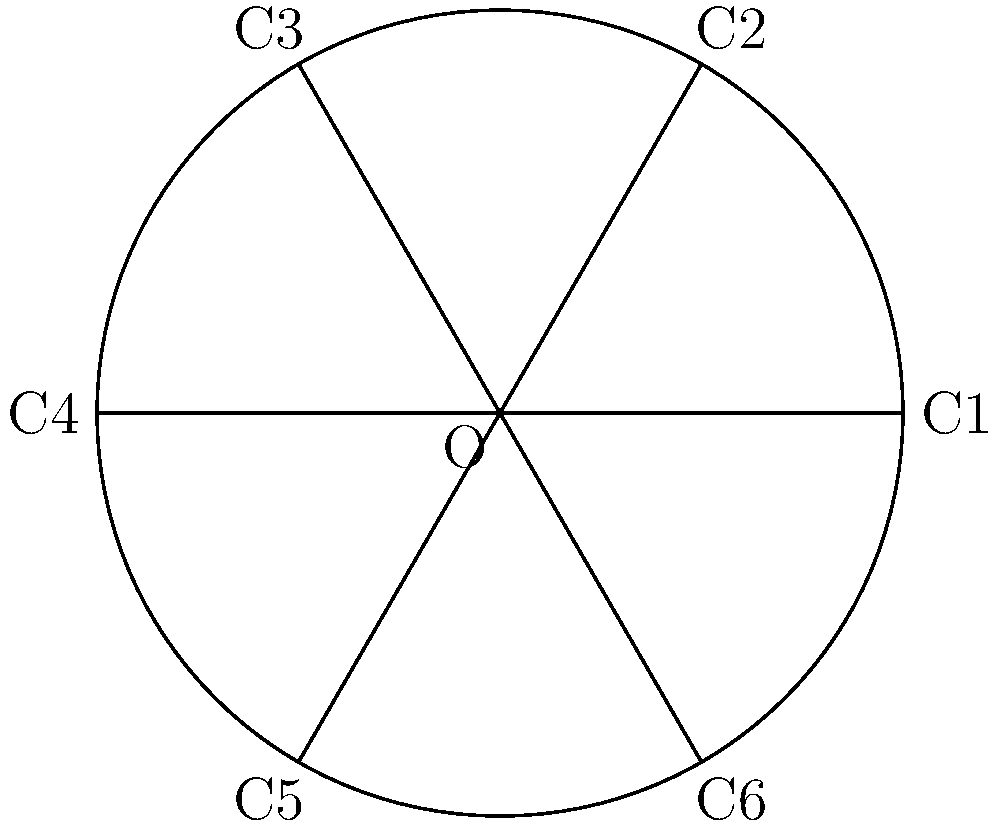A circular crop field is divided into 6 equal sectors for crop rotation, as shown in the diagram. Each sector is labeled C1 to C6. How many symmetry operations (including the identity) does this crop rotation pattern have? To determine the number of symmetry operations, we need to consider both rotational and reflectional symmetries:

1. Rotational symmetry:
   - Identity (0° rotation)
   - 60° rotation (clockwise and counterclockwise)
   - 120° rotation (clockwise and counterclockwise)
   - 180° rotation

2. Reflectional symmetry:
   - 6 lines of reflection (through each diameter)

Counting these symmetries:
- Rotational symmetries: 6 (including identity)
- Reflectional symmetries: 6

Total number of symmetry operations: 6 + 6 = 12

This crop rotation pattern forms a dihedral group $D_6$, which has order 12.
Answer: 12 